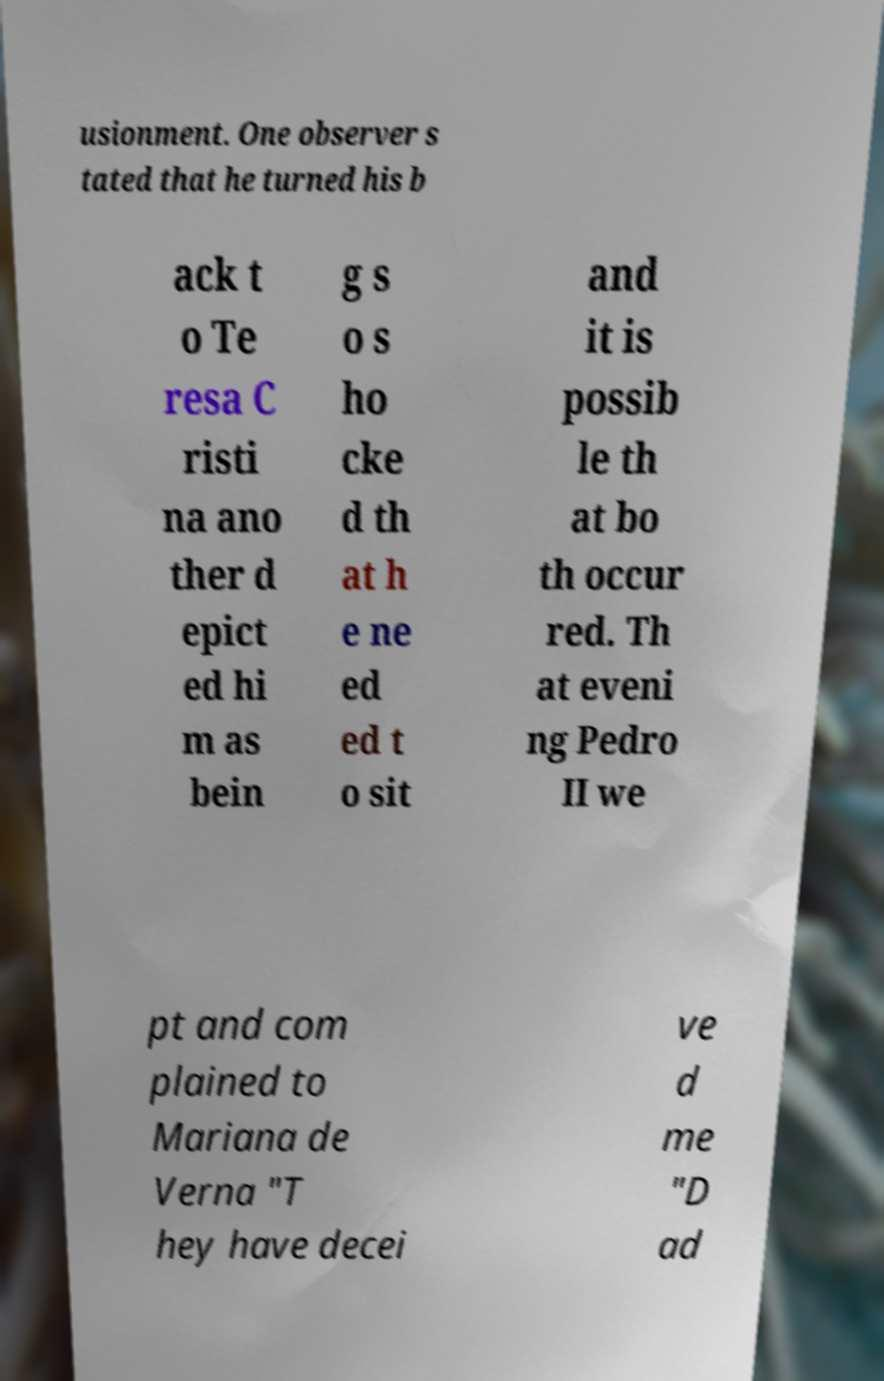Can you read and provide the text displayed in the image?This photo seems to have some interesting text. Can you extract and type it out for me? usionment. One observer s tated that he turned his b ack t o Te resa C risti na ano ther d epict ed hi m as bein g s o s ho cke d th at h e ne ed ed t o sit and it is possib le th at bo th occur red. Th at eveni ng Pedro II we pt and com plained to Mariana de Verna "T hey have decei ve d me "D ad 